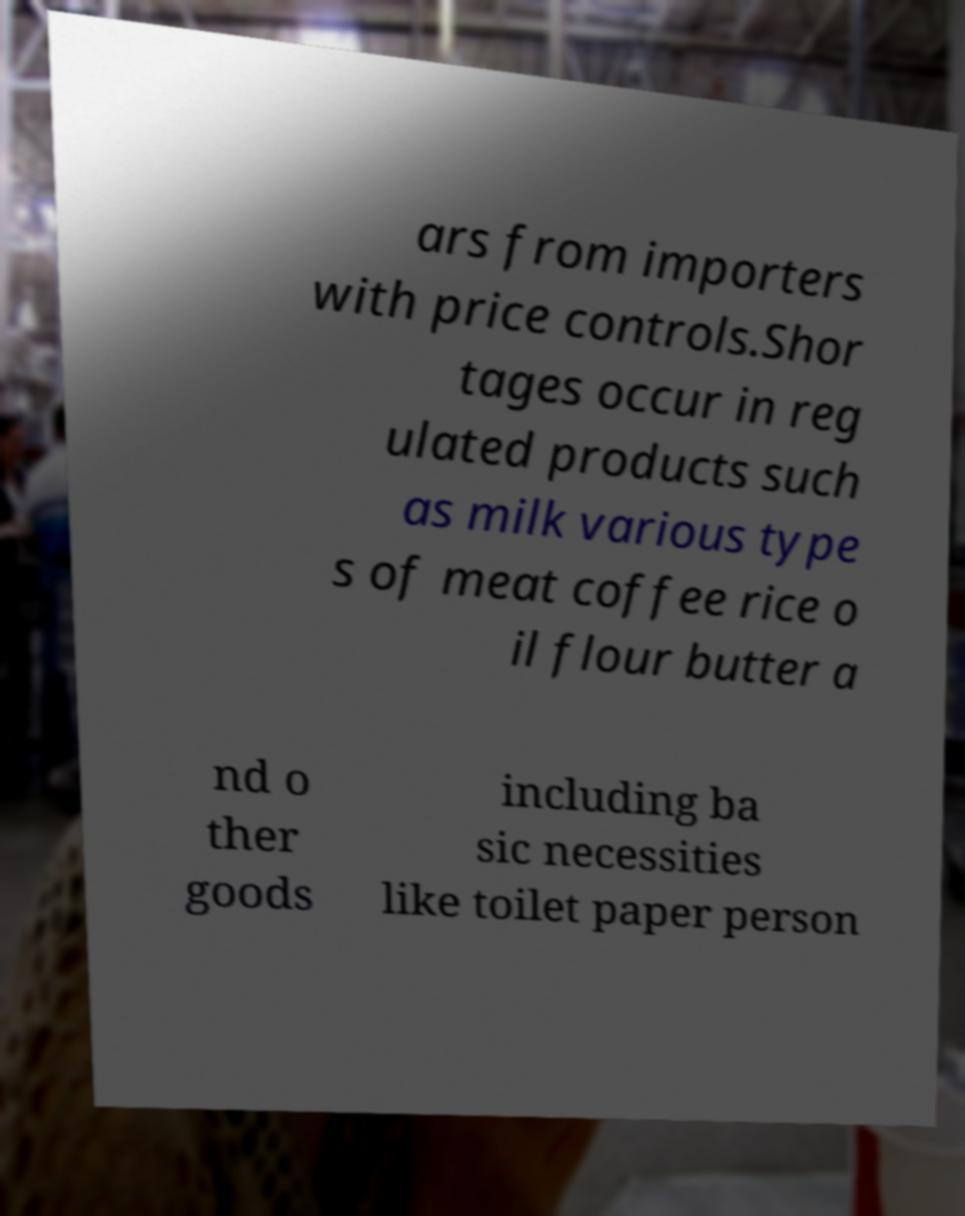For documentation purposes, I need the text within this image transcribed. Could you provide that? ars from importers with price controls.Shor tages occur in reg ulated products such as milk various type s of meat coffee rice o il flour butter a nd o ther goods including ba sic necessities like toilet paper person 